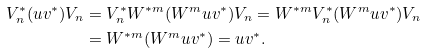<formula> <loc_0><loc_0><loc_500><loc_500>V _ { n } ^ { * } ( u v ^ { * } ) V _ { n } & = V _ { n } ^ { * } W ^ { * m } ( W ^ { m } u v ^ { * } ) V _ { n } = W ^ { * m } V _ { n } ^ { * } ( W ^ { m } u v ^ { * } ) V _ { n } \\ & = W ^ { * m } ( W ^ { m } u v ^ { * } ) = u v ^ { * } .</formula> 